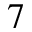<formula> <loc_0><loc_0><loc_500><loc_500>^ { 7 }</formula> 